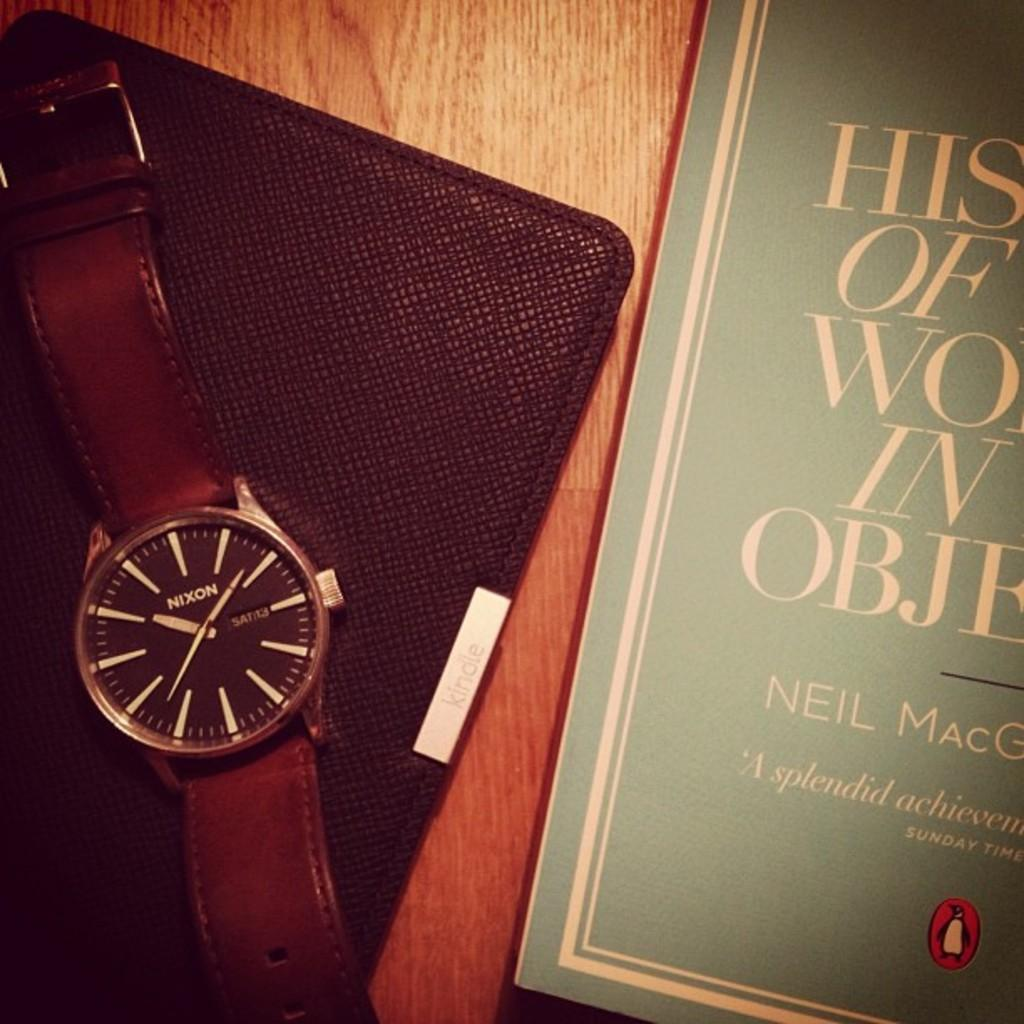Provide a one-sentence caption for the provided image. the face of a Nixon branded wrist watch whos time reads 10:39 and is sitting next to a book. 